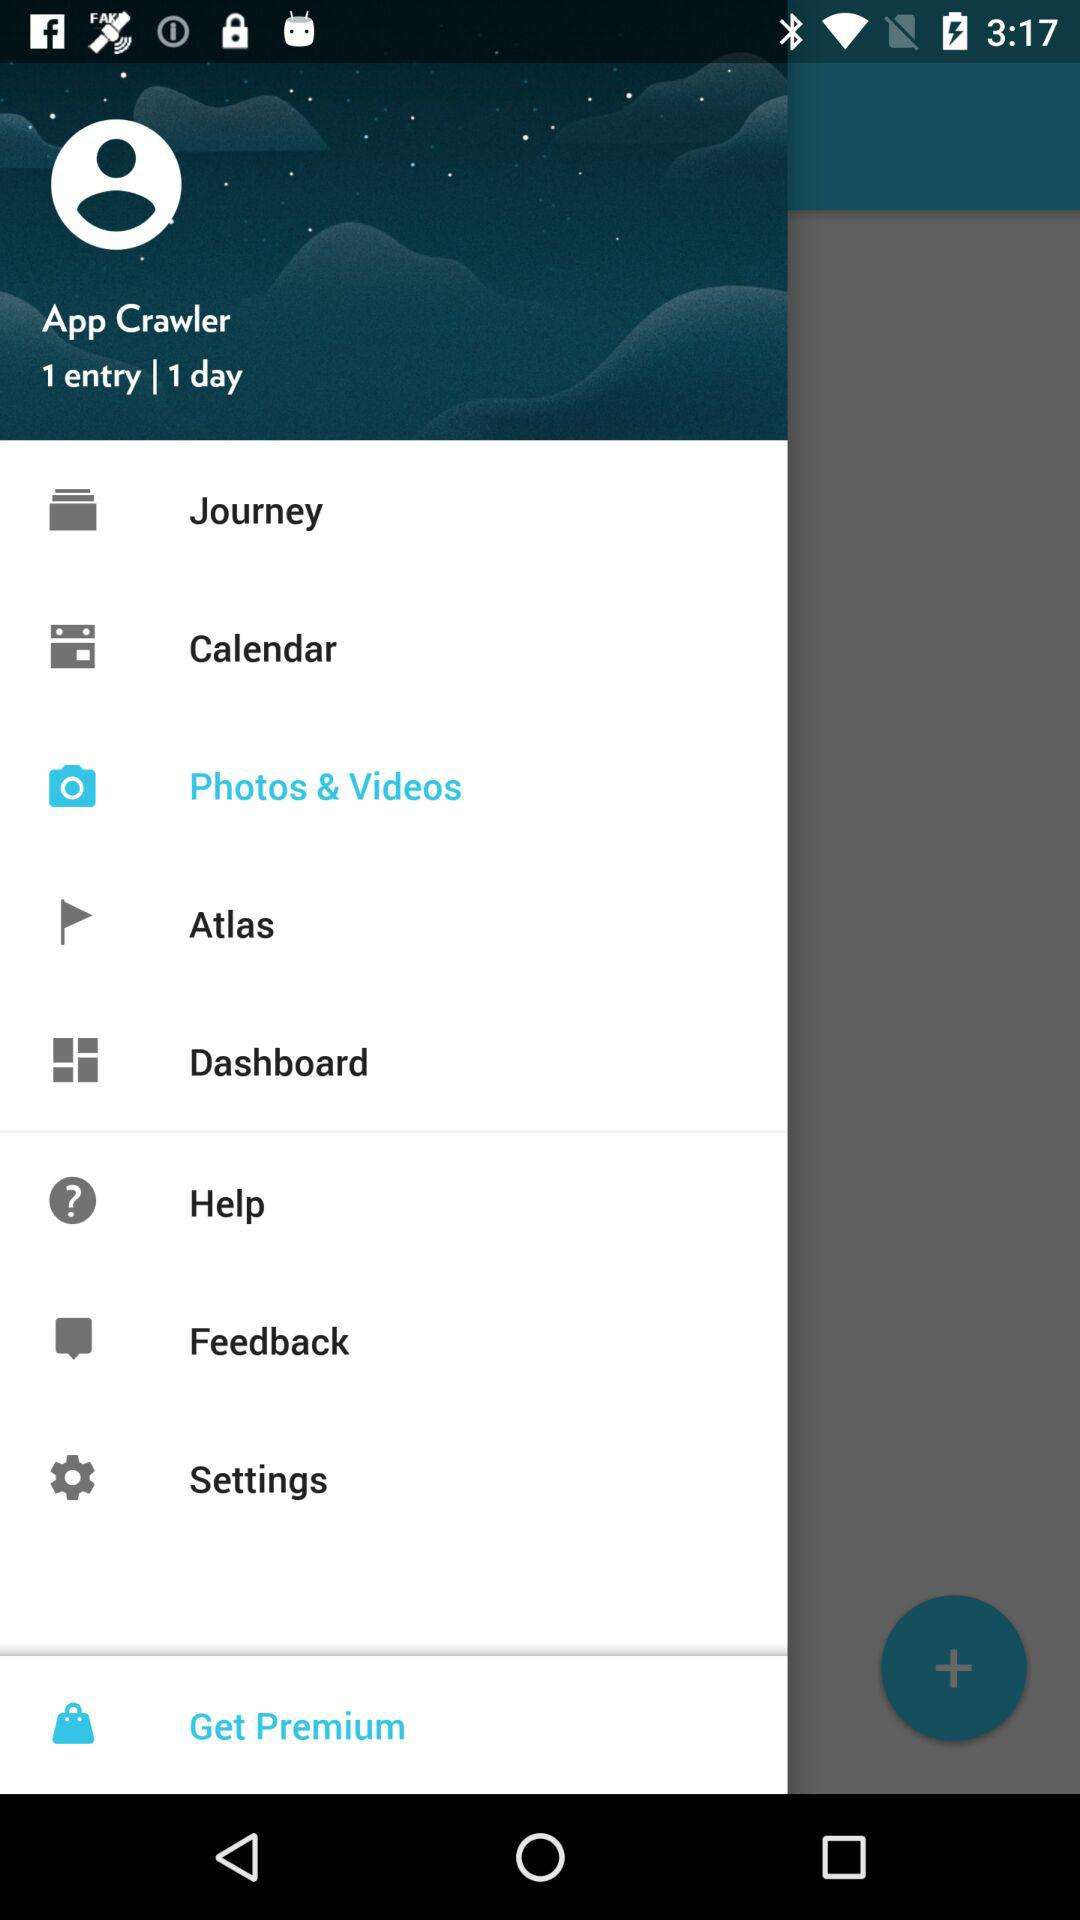What is the user name? The user name is App Crawler. 